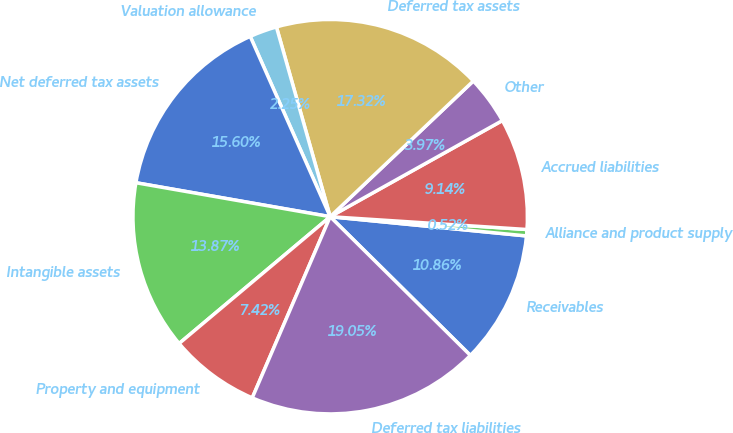Convert chart. <chart><loc_0><loc_0><loc_500><loc_500><pie_chart><fcel>Receivables<fcel>Alliance and product supply<fcel>Accrued liabilities<fcel>Other<fcel>Deferred tax assets<fcel>Valuation allowance<fcel>Net deferred tax assets<fcel>Intangible assets<fcel>Property and equipment<fcel>Deferred tax liabilities<nl><fcel>10.86%<fcel>0.52%<fcel>9.14%<fcel>3.97%<fcel>17.32%<fcel>2.25%<fcel>15.6%<fcel>13.87%<fcel>7.42%<fcel>19.05%<nl></chart> 